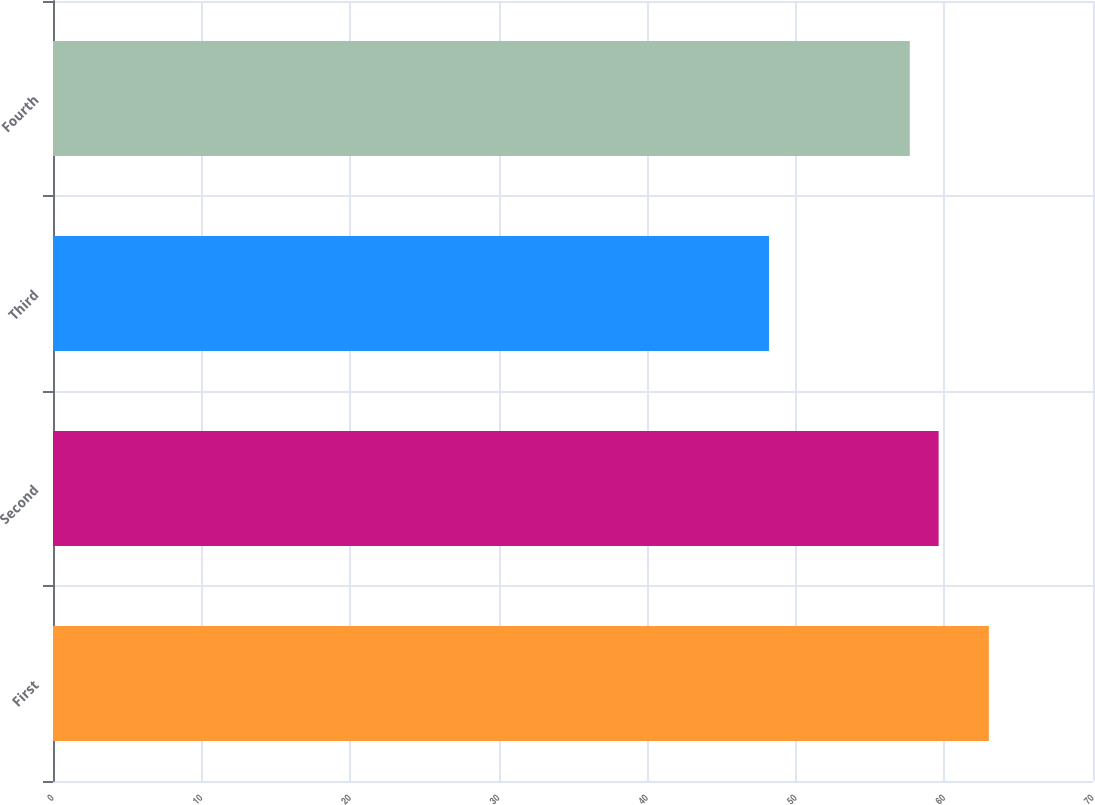Convert chart to OTSL. <chart><loc_0><loc_0><loc_500><loc_500><bar_chart><fcel>First<fcel>Second<fcel>Third<fcel>Fourth<nl><fcel>62.99<fcel>59.61<fcel>48.19<fcel>57.67<nl></chart> 